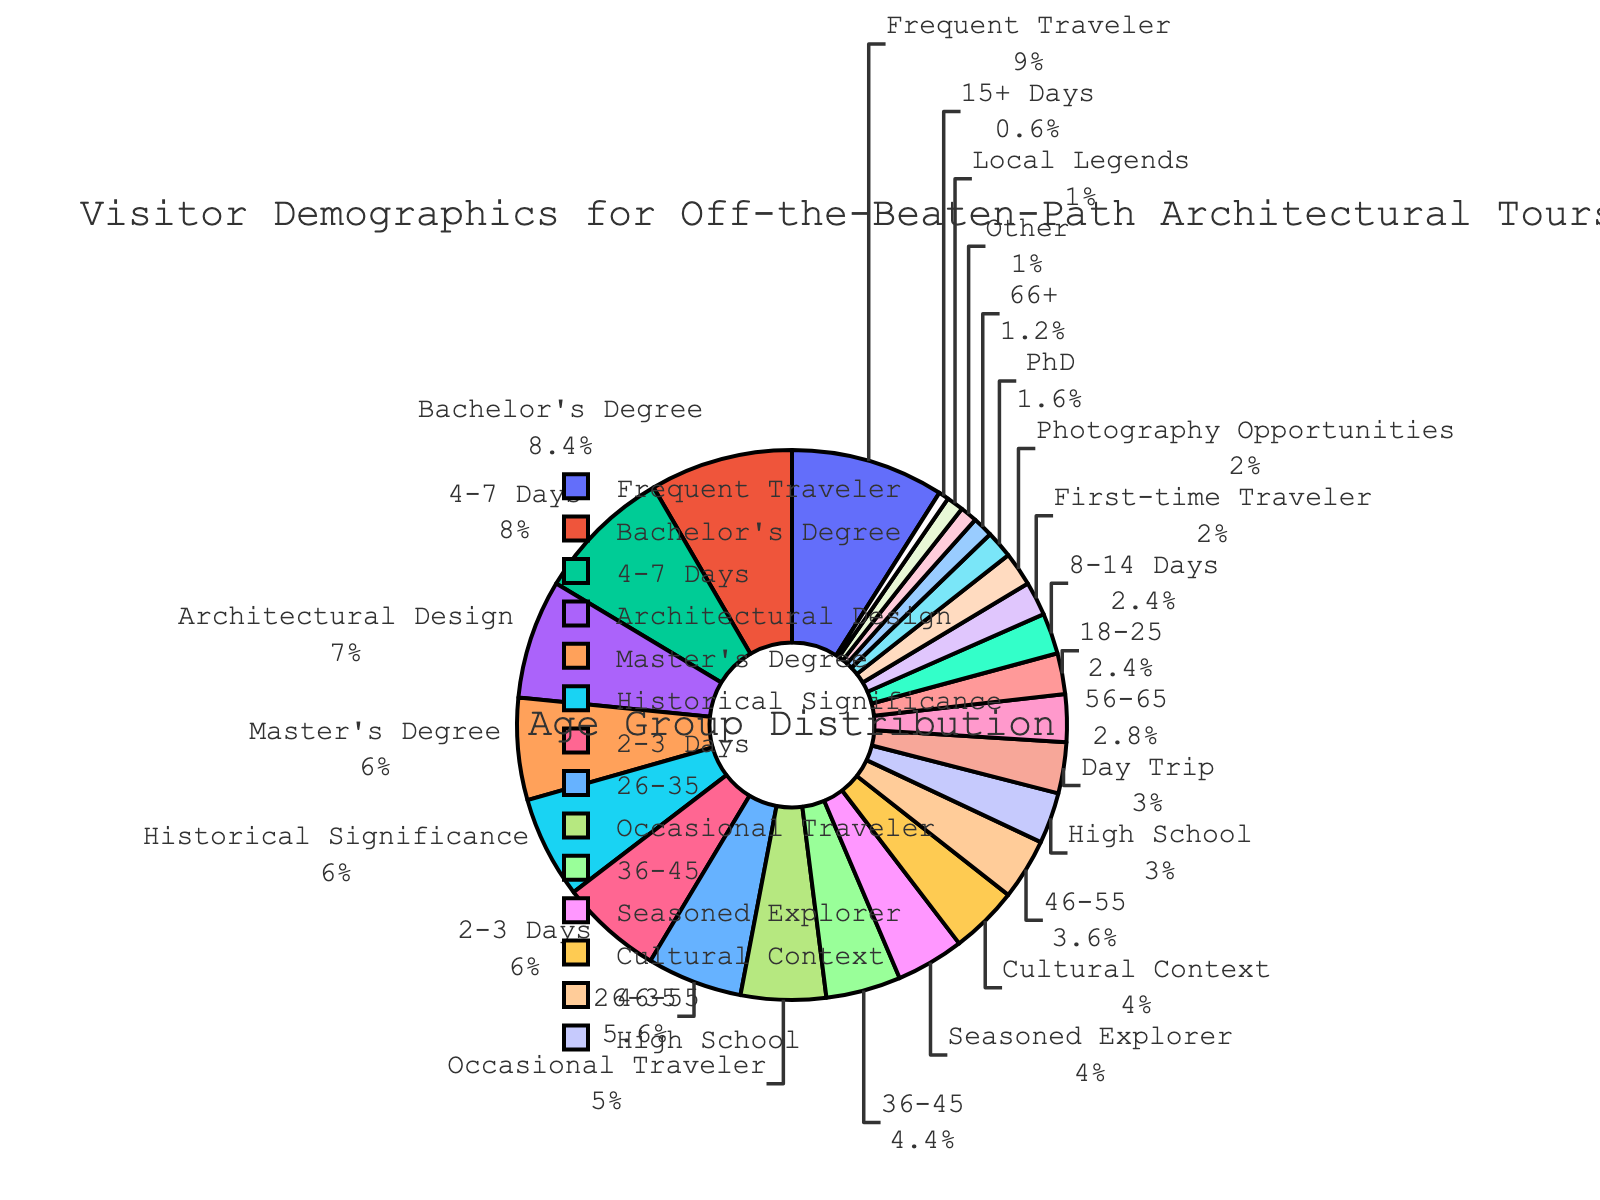What is the percentage of visitors in the 26-35 age group? Look at the segment labeled 26-35 in the pie chart. The percentage directly shown is 28%.
Answer: 28% What is the sum of the percentages for the 46-55 and 56-65 age groups? The chart shows that the 46-55 age group has 18% and the 56-65 age group has 14%. Summing these percentages gives 18% + 14% = 32%.
Answer: 32% Which age group has the lowest percentage of visitors? Identify the smallest segment in the pie chart. The 66+ age group segment looks the smallest and is labeled with 6%.
Answer: 66+ How many age groups have a greater percentage than 12%? Examine the pie chart and count the segments that have percentages higher than 12%. These segments are 26-35 (28%), 36-45 (22%), 46-55 (18%), and 56-65 (14%). There are 4 groups.
Answer: 4 What is the difference in percentage between the 18-25 and 36-45 age groups? The chart shows the 18-25 age group at 12% and the 36-45 group at 22%. The difference is calculated as 22% - 12% = 10%.
Answer: 10% Which age group has a percentage closest to one-fourth of the total visitors? Calculate one-fourth of 100%, which is 25%. Then find the segment closest to 25%. The 26-35 age group has 28%, which is closest to 25%.
Answer: 26-35 